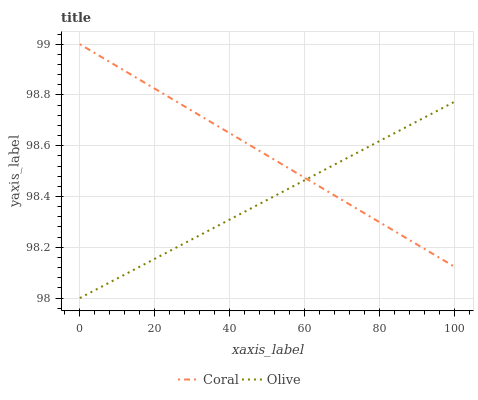Does Olive have the minimum area under the curve?
Answer yes or no. Yes. Does Coral have the maximum area under the curve?
Answer yes or no. Yes. Does Coral have the minimum area under the curve?
Answer yes or no. No. Is Coral the smoothest?
Answer yes or no. Yes. Is Olive the roughest?
Answer yes or no. Yes. Is Coral the roughest?
Answer yes or no. No. Does Olive have the lowest value?
Answer yes or no. Yes. Does Coral have the lowest value?
Answer yes or no. No. Does Coral have the highest value?
Answer yes or no. Yes. Does Olive intersect Coral?
Answer yes or no. Yes. Is Olive less than Coral?
Answer yes or no. No. Is Olive greater than Coral?
Answer yes or no. No. 